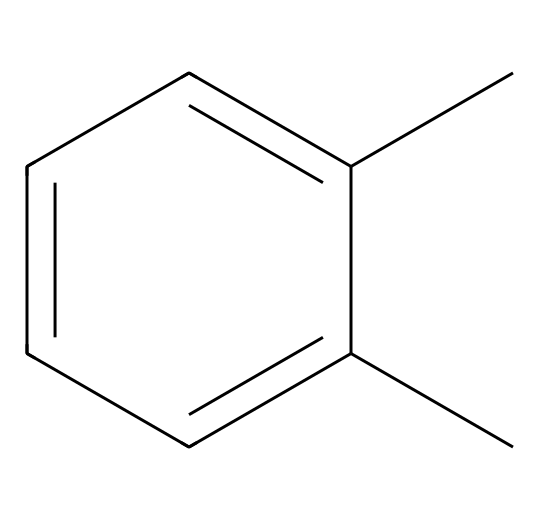What is the chemical name of this compound? The SMILES representation shows a compound with a benzene ring and an additional methyl group, which indicates it is xylene.
Answer: xylene How many carbon atoms are present in this molecule? Analyzing the SMILES, there are 8 carbon atoms in total: 6 from the benzene ring and 2 from the methyl groups.
Answer: 8 What type of molecule is xylene classified as? Xylene has a structure that suggests it is an aromatic hydrocarbon due to the presence of the benzene ring within its structure.
Answer: aromatic hydrocarbon How many hydrogen atoms are attached to the carbon structure? Each carbon in the methyl groups contributes 3 hydrogen atoms, while the benzene ring carbons contribute 4 hydrogen atoms (considering bonding). Therefore, 10 hydrogen atoms in total are present.
Answer: 10 What is the primary use of xylene in restoration work? Xylene is primarily used as a solvent in the cleaning and restoration of ancient artifacts, making it important in the field of conservation.
Answer: solvent What type of functional groups can be inferred from the structure of xylene? The presence of the benzene ring indicates that xylene contains aromatic functional groups, specifically alkyl groups.
Answer: aromatic, alkyl 